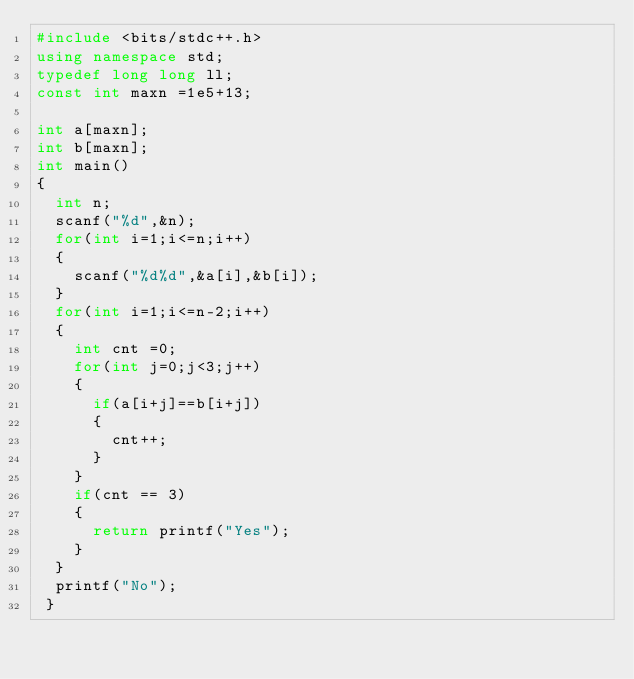Convert code to text. <code><loc_0><loc_0><loc_500><loc_500><_C++_>#include <bits/stdc++.h>
using namespace std;
typedef long long ll;
const int maxn =1e5+13;

int a[maxn];
int b[maxn];
int main()
{
	int n;
	scanf("%d",&n);
	for(int i=1;i<=n;i++)
	{
		scanf("%d%d",&a[i],&b[i]);
	}
	for(int i=1;i<=n-2;i++)
	{
		int cnt =0;
		for(int j=0;j<3;j++)
		{
			if(a[i+j]==b[i+j])
			{
				cnt++;
			}
		}
		if(cnt == 3)
		{
			return printf("Yes");
		}
	}
	printf("No");
 } </code> 